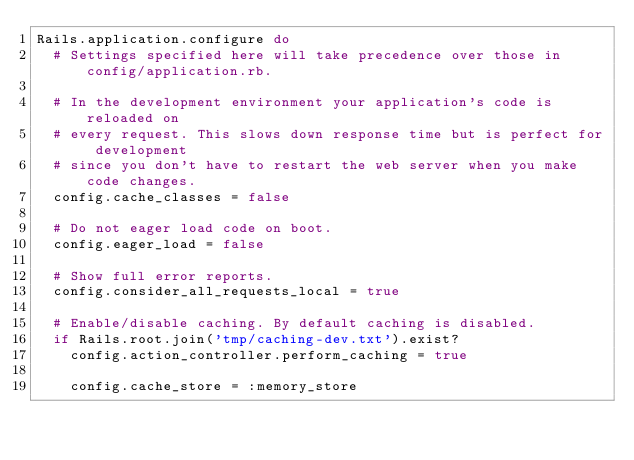Convert code to text. <code><loc_0><loc_0><loc_500><loc_500><_Ruby_>Rails.application.configure do
  # Settings specified here will take precedence over those in config/application.rb.

  # In the development environment your application's code is reloaded on
  # every request. This slows down response time but is perfect for development
  # since you don't have to restart the web server when you make code changes.
  config.cache_classes = false

  # Do not eager load code on boot.
  config.eager_load = false

  # Show full error reports.
  config.consider_all_requests_local = true

  # Enable/disable caching. By default caching is disabled.
  if Rails.root.join('tmp/caching-dev.txt').exist?
    config.action_controller.perform_caching = true

    config.cache_store = :memory_store</code> 